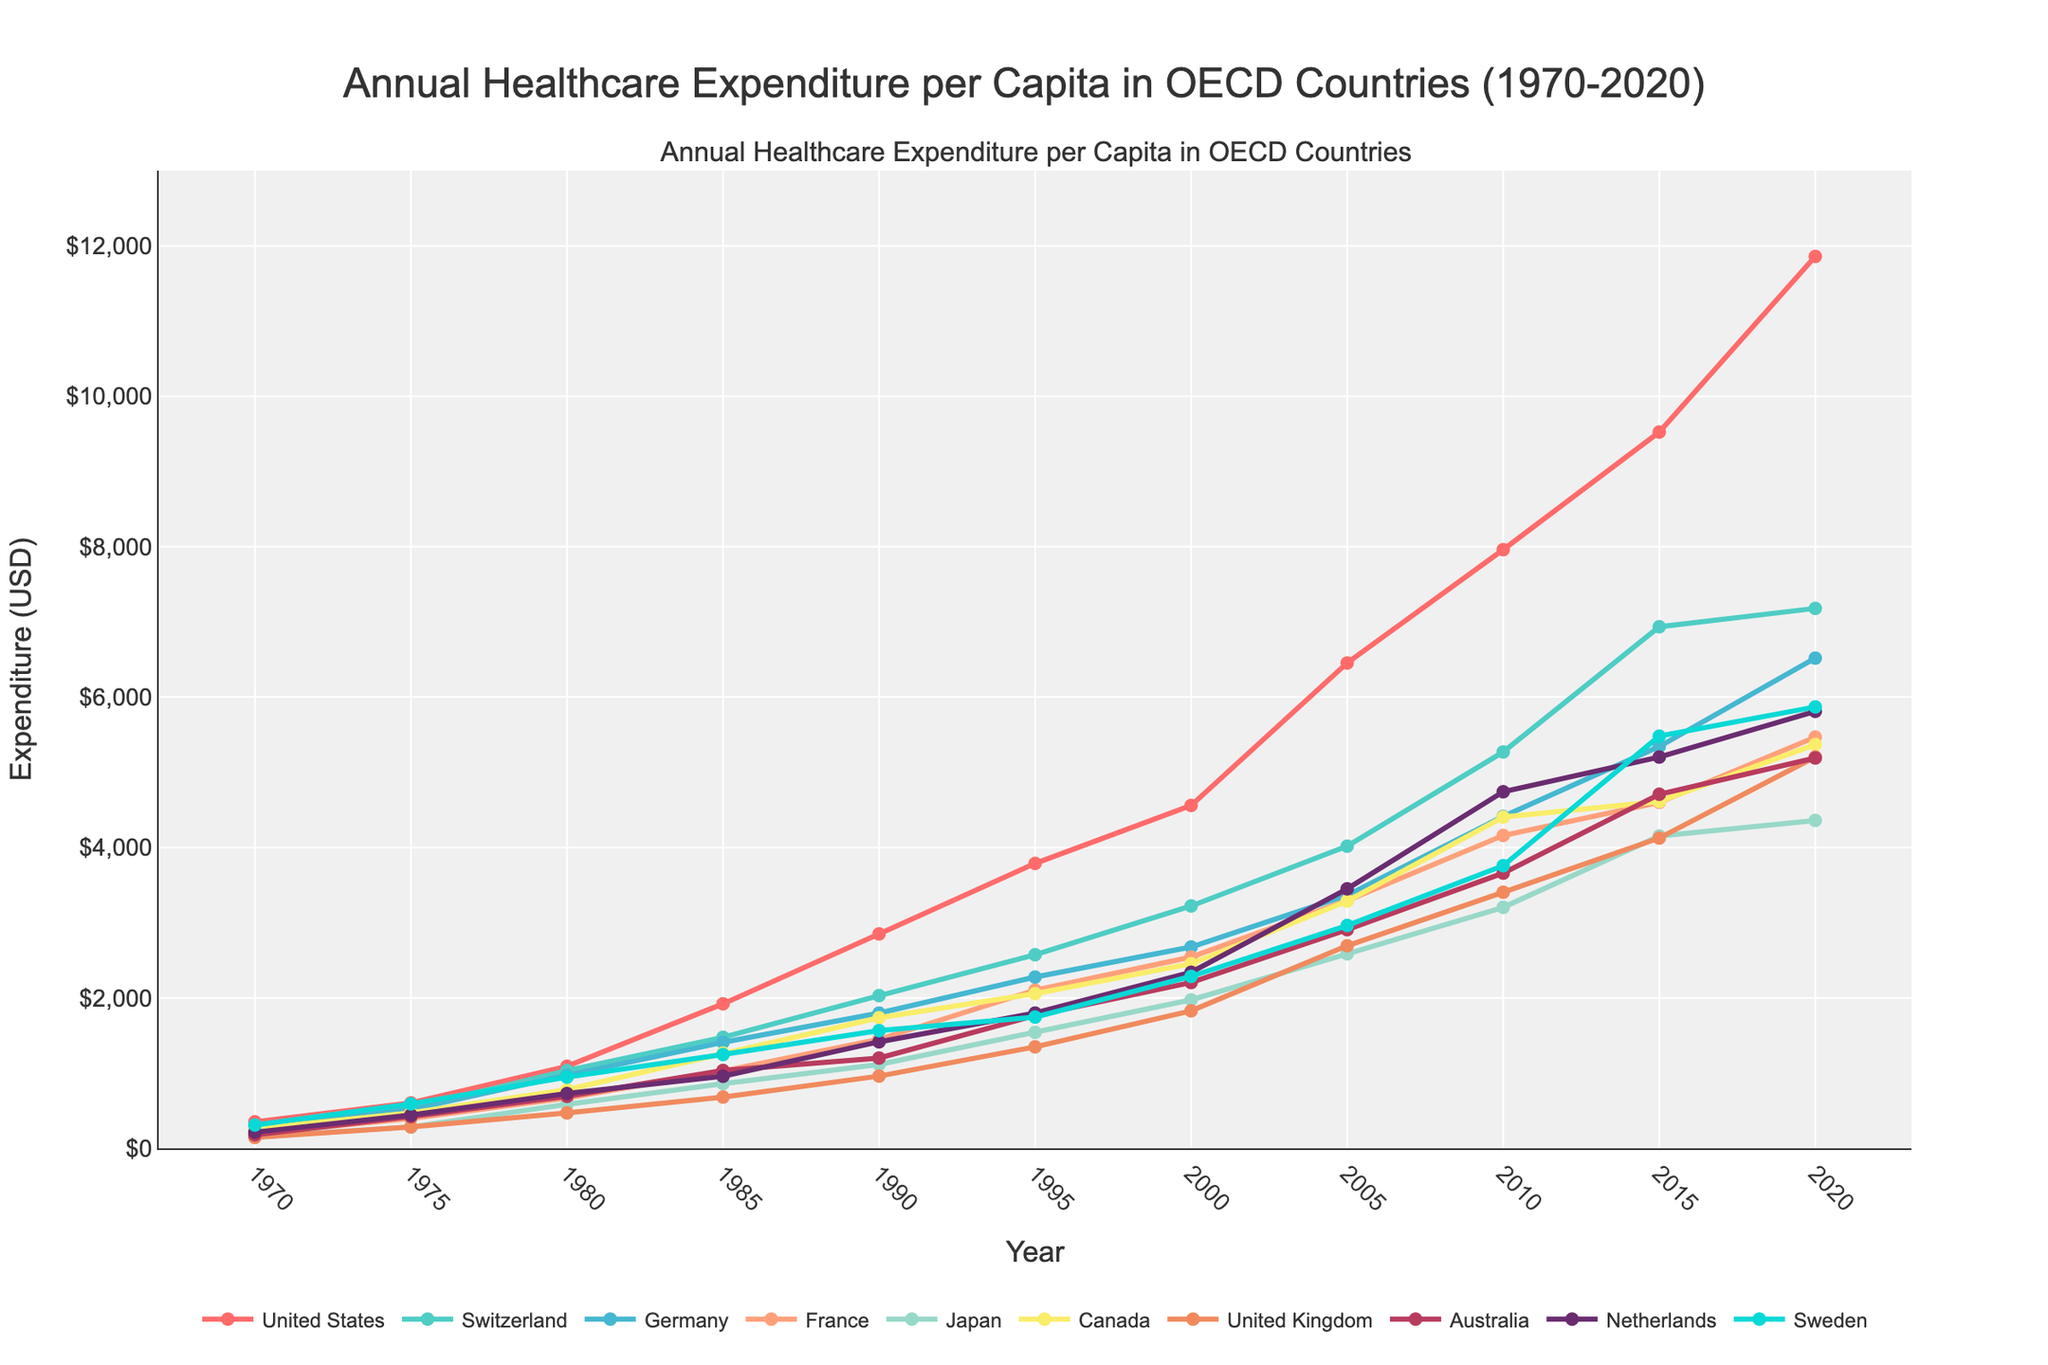Which country had the highest healthcare expenditure per capita in 2020? Look at the year 2020 on the x-axis and identify the highest point among the countries. The United States has the highest expenditure in 2020.
Answer: United States How did Japan's healthcare expenditure per capita change from 1980 to 2000? Observe and subtract Japan's expenditure in 1980 and 2000. In 1980, it was 585. In 2000, it was 1974. The change is 1974 - 585.
Answer: 1389 Which country had a higher healthcare expenditure per capita in 1995, Canada or United Kingdom? Look at the year 1995 on the x-axis and compare the points corresponding to Canada and the United Kingdom. Canada has a higher expenditure than the United Kingdom.
Answer: Canada What is the average healthcare expenditure per capita in Australia across the given years? Sum the expenditure values for Australia from 1970 to 2020 and divide by the number of years (10).
Answer: 3055.4 What is the trend in healthcare expenditure per capita in Germany from 1970 to 2020? Examine the line representing Germany from 1970 to 2020. The trend shows a steady increase over the years.
Answer: Increasing Which year did France's healthcare expenditure per capita closely follow the expenditure of Canada? Find the points where France's expenditure closely matches Canada's. In 2020, France's expenditure (5468) is close to Canada's (5370).
Answer: 2020 By how much did the healthcare expenditure per capita in the United States increase from 1990 to 2000? Find the expenditures for the United States in 1990 and 2000. Subtract the 1990 value from the 2000 value. 4559 - 2851 = 1708.
Answer: 1708 Which country had the lowest healthcare expenditure per capita in 1970? Look at the year 1970 on the x-axis and identify the lowest point among the countries. The United Kingdom has the lowest expenditure in 1970.
Answer: United Kingdom Was Japan's healthcare expenditure per capita in 1980 greater than Germany's in 1975? Compare Japan's expenditure in 1980 (585) with Germany's in 1975 (515). Japan's expenditure is greater.
Answer: Yes What is the difference in the healthcare expenditure per capita between Netherlands and Sweden in 2010? Compare the values for Netherlands (4741) and Sweden (3758) in 2010. Subtract Sweden's value from Netherlands'.
Answer: 983 